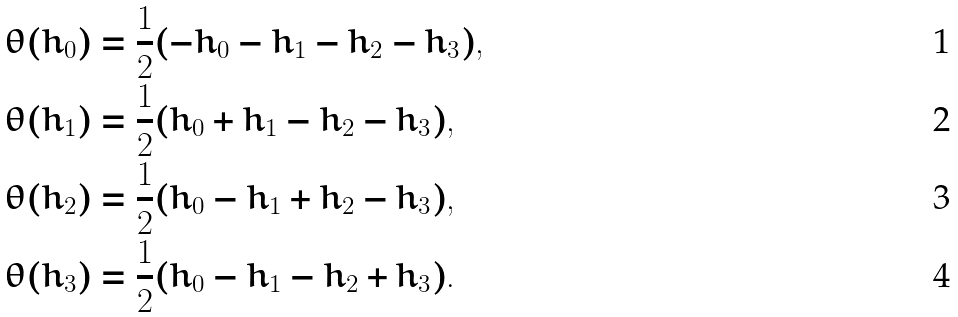Convert formula to latex. <formula><loc_0><loc_0><loc_500><loc_500>\theta ( h _ { 0 } ) & = \frac { 1 } { 2 } ( - h _ { 0 } - h _ { 1 } - h _ { 2 } - h _ { 3 } ) , \\ \theta ( h _ { 1 } ) & = \frac { 1 } { 2 } ( h _ { 0 } + h _ { 1 } - h _ { 2 } - h _ { 3 } ) , \\ \theta ( h _ { 2 } ) & = \frac { 1 } { 2 } ( h _ { 0 } - h _ { 1 } + h _ { 2 } - h _ { 3 } ) , \\ \theta ( h _ { 3 } ) & = \frac { 1 } { 2 } ( h _ { 0 } - h _ { 1 } - h _ { 2 } + h _ { 3 } ) .</formula> 